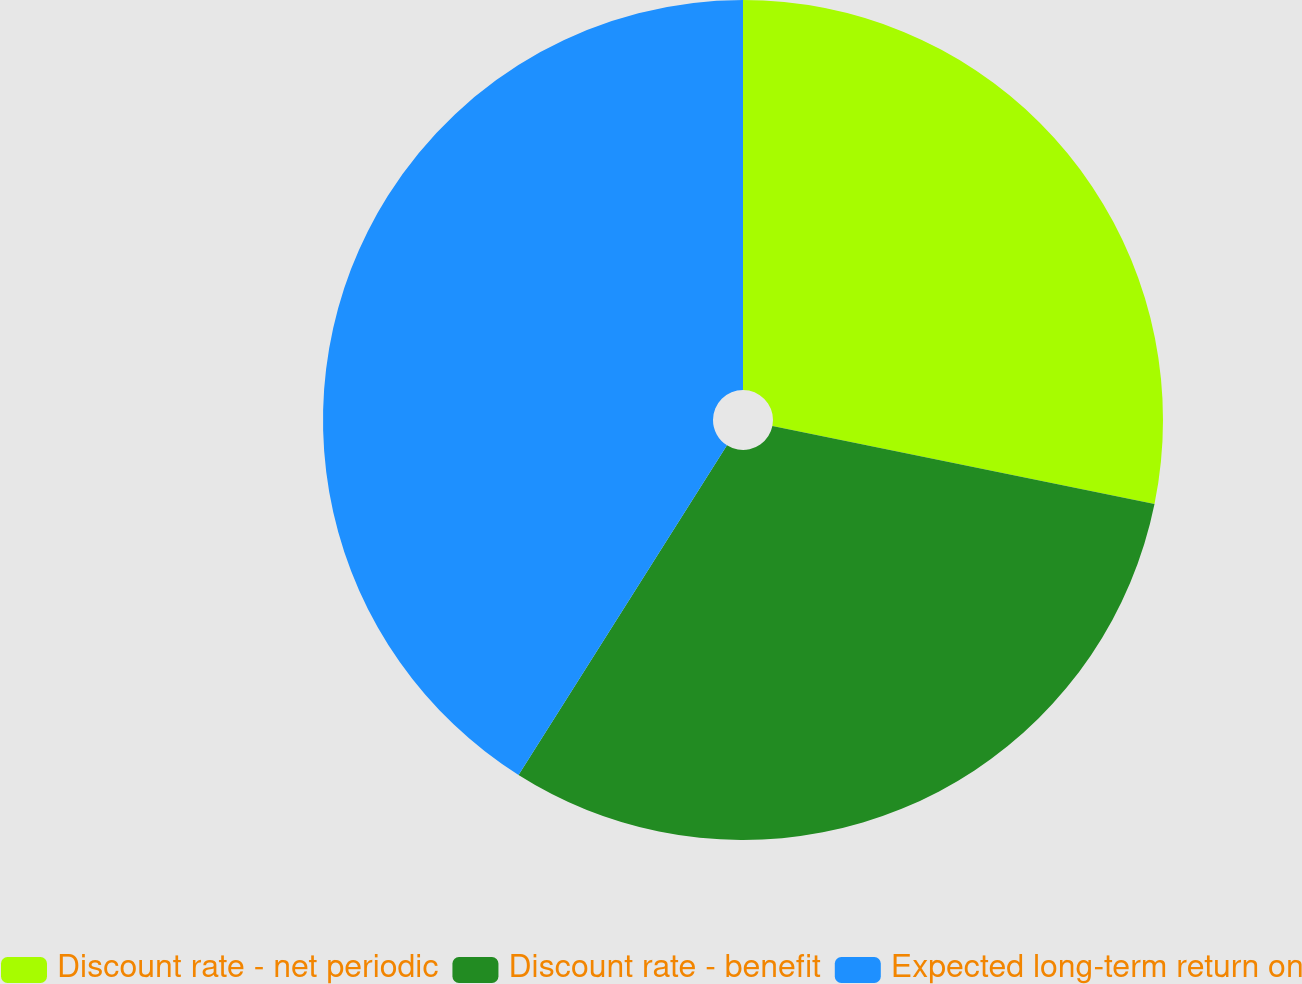<chart> <loc_0><loc_0><loc_500><loc_500><pie_chart><fcel>Discount rate - net periodic<fcel>Discount rate - benefit<fcel>Expected long-term return on<nl><fcel>28.21%<fcel>30.77%<fcel>41.03%<nl></chart> 